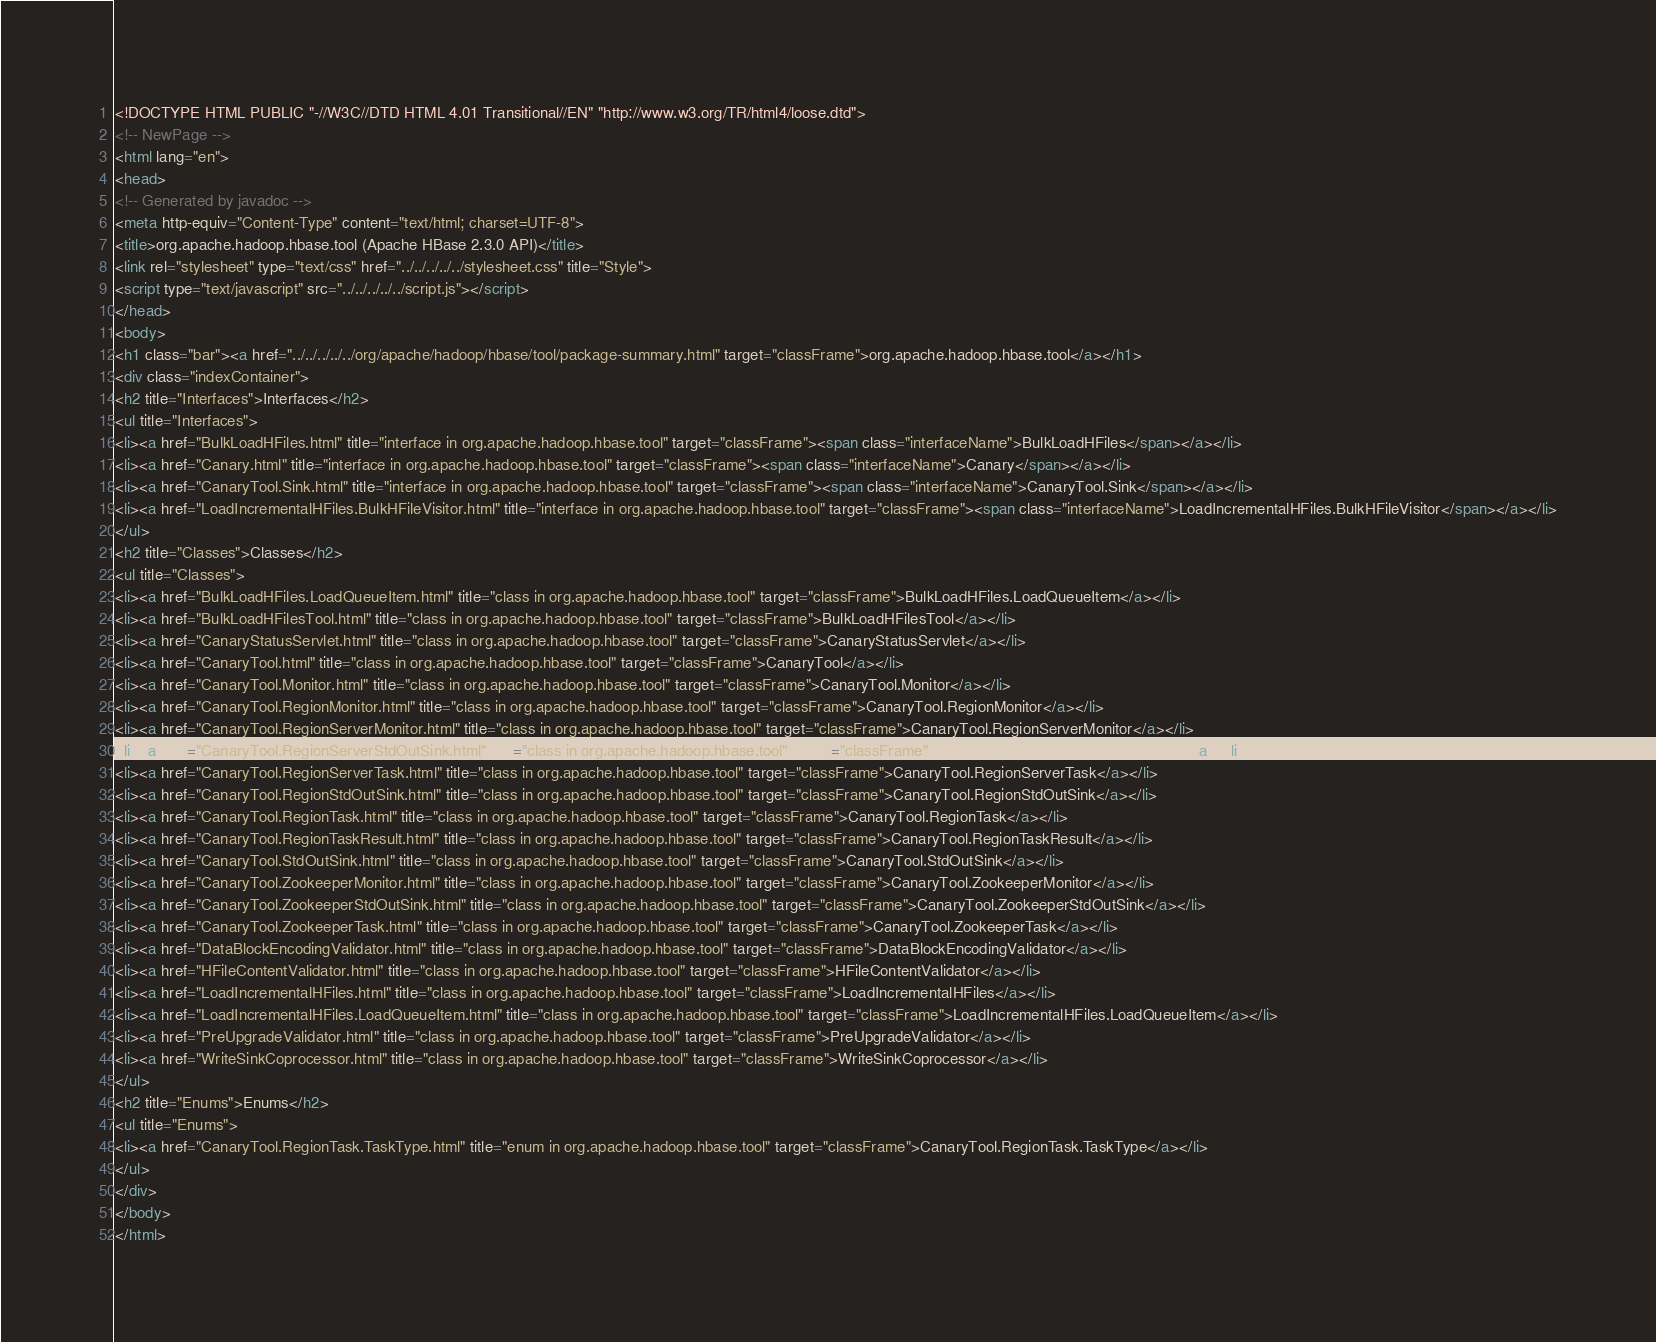<code> <loc_0><loc_0><loc_500><loc_500><_HTML_><!DOCTYPE HTML PUBLIC "-//W3C//DTD HTML 4.01 Transitional//EN" "http://www.w3.org/TR/html4/loose.dtd">
<!-- NewPage -->
<html lang="en">
<head>
<!-- Generated by javadoc -->
<meta http-equiv="Content-Type" content="text/html; charset=UTF-8">
<title>org.apache.hadoop.hbase.tool (Apache HBase 2.3.0 API)</title>
<link rel="stylesheet" type="text/css" href="../../../../../stylesheet.css" title="Style">
<script type="text/javascript" src="../../../../../script.js"></script>
</head>
<body>
<h1 class="bar"><a href="../../../../../org/apache/hadoop/hbase/tool/package-summary.html" target="classFrame">org.apache.hadoop.hbase.tool</a></h1>
<div class="indexContainer">
<h2 title="Interfaces">Interfaces</h2>
<ul title="Interfaces">
<li><a href="BulkLoadHFiles.html" title="interface in org.apache.hadoop.hbase.tool" target="classFrame"><span class="interfaceName">BulkLoadHFiles</span></a></li>
<li><a href="Canary.html" title="interface in org.apache.hadoop.hbase.tool" target="classFrame"><span class="interfaceName">Canary</span></a></li>
<li><a href="CanaryTool.Sink.html" title="interface in org.apache.hadoop.hbase.tool" target="classFrame"><span class="interfaceName">CanaryTool.Sink</span></a></li>
<li><a href="LoadIncrementalHFiles.BulkHFileVisitor.html" title="interface in org.apache.hadoop.hbase.tool" target="classFrame"><span class="interfaceName">LoadIncrementalHFiles.BulkHFileVisitor</span></a></li>
</ul>
<h2 title="Classes">Classes</h2>
<ul title="Classes">
<li><a href="BulkLoadHFiles.LoadQueueItem.html" title="class in org.apache.hadoop.hbase.tool" target="classFrame">BulkLoadHFiles.LoadQueueItem</a></li>
<li><a href="BulkLoadHFilesTool.html" title="class in org.apache.hadoop.hbase.tool" target="classFrame">BulkLoadHFilesTool</a></li>
<li><a href="CanaryStatusServlet.html" title="class in org.apache.hadoop.hbase.tool" target="classFrame">CanaryStatusServlet</a></li>
<li><a href="CanaryTool.html" title="class in org.apache.hadoop.hbase.tool" target="classFrame">CanaryTool</a></li>
<li><a href="CanaryTool.Monitor.html" title="class in org.apache.hadoop.hbase.tool" target="classFrame">CanaryTool.Monitor</a></li>
<li><a href="CanaryTool.RegionMonitor.html" title="class in org.apache.hadoop.hbase.tool" target="classFrame">CanaryTool.RegionMonitor</a></li>
<li><a href="CanaryTool.RegionServerMonitor.html" title="class in org.apache.hadoop.hbase.tool" target="classFrame">CanaryTool.RegionServerMonitor</a></li>
<li><a href="CanaryTool.RegionServerStdOutSink.html" title="class in org.apache.hadoop.hbase.tool" target="classFrame">CanaryTool.RegionServerStdOutSink</a></li>
<li><a href="CanaryTool.RegionServerTask.html" title="class in org.apache.hadoop.hbase.tool" target="classFrame">CanaryTool.RegionServerTask</a></li>
<li><a href="CanaryTool.RegionStdOutSink.html" title="class in org.apache.hadoop.hbase.tool" target="classFrame">CanaryTool.RegionStdOutSink</a></li>
<li><a href="CanaryTool.RegionTask.html" title="class in org.apache.hadoop.hbase.tool" target="classFrame">CanaryTool.RegionTask</a></li>
<li><a href="CanaryTool.RegionTaskResult.html" title="class in org.apache.hadoop.hbase.tool" target="classFrame">CanaryTool.RegionTaskResult</a></li>
<li><a href="CanaryTool.StdOutSink.html" title="class in org.apache.hadoop.hbase.tool" target="classFrame">CanaryTool.StdOutSink</a></li>
<li><a href="CanaryTool.ZookeeperMonitor.html" title="class in org.apache.hadoop.hbase.tool" target="classFrame">CanaryTool.ZookeeperMonitor</a></li>
<li><a href="CanaryTool.ZookeeperStdOutSink.html" title="class in org.apache.hadoop.hbase.tool" target="classFrame">CanaryTool.ZookeeperStdOutSink</a></li>
<li><a href="CanaryTool.ZookeeperTask.html" title="class in org.apache.hadoop.hbase.tool" target="classFrame">CanaryTool.ZookeeperTask</a></li>
<li><a href="DataBlockEncodingValidator.html" title="class in org.apache.hadoop.hbase.tool" target="classFrame">DataBlockEncodingValidator</a></li>
<li><a href="HFileContentValidator.html" title="class in org.apache.hadoop.hbase.tool" target="classFrame">HFileContentValidator</a></li>
<li><a href="LoadIncrementalHFiles.html" title="class in org.apache.hadoop.hbase.tool" target="classFrame">LoadIncrementalHFiles</a></li>
<li><a href="LoadIncrementalHFiles.LoadQueueItem.html" title="class in org.apache.hadoop.hbase.tool" target="classFrame">LoadIncrementalHFiles.LoadQueueItem</a></li>
<li><a href="PreUpgradeValidator.html" title="class in org.apache.hadoop.hbase.tool" target="classFrame">PreUpgradeValidator</a></li>
<li><a href="WriteSinkCoprocessor.html" title="class in org.apache.hadoop.hbase.tool" target="classFrame">WriteSinkCoprocessor</a></li>
</ul>
<h2 title="Enums">Enums</h2>
<ul title="Enums">
<li><a href="CanaryTool.RegionTask.TaskType.html" title="enum in org.apache.hadoop.hbase.tool" target="classFrame">CanaryTool.RegionTask.TaskType</a></li>
</ul>
</div>
</body>
</html>
</code> 